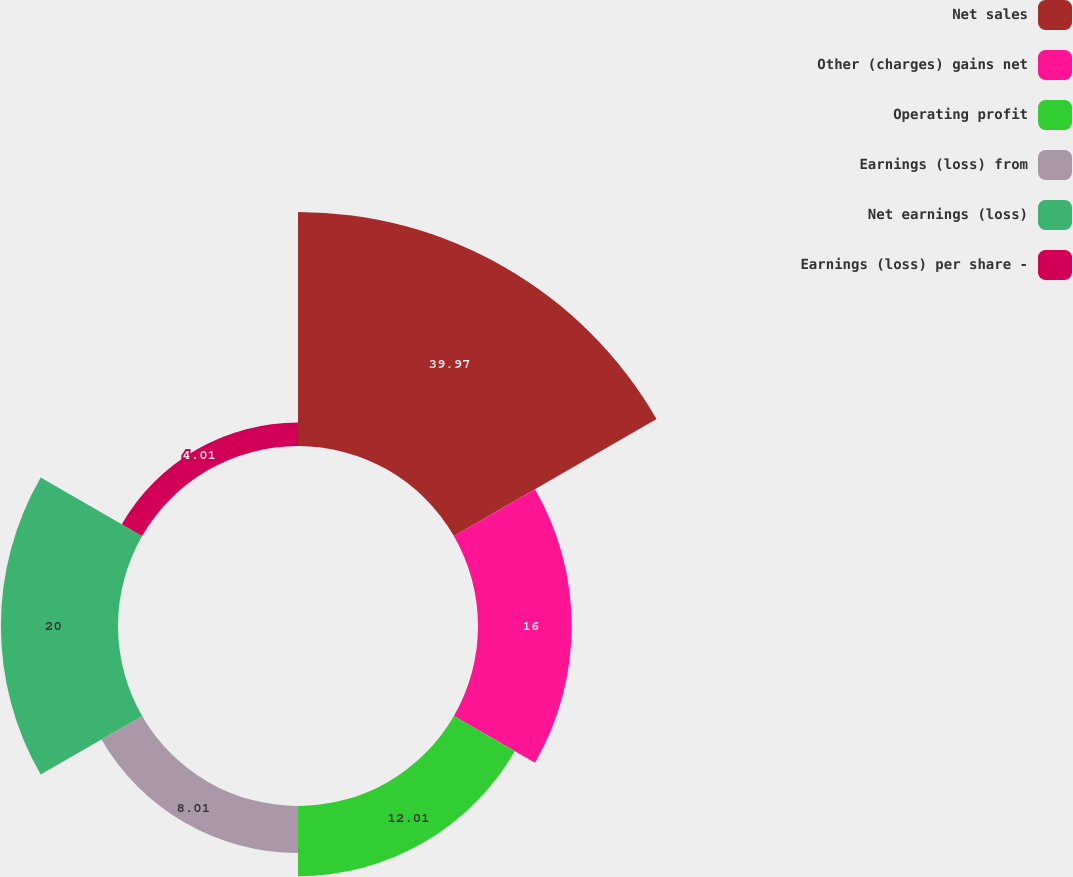Convert chart. <chart><loc_0><loc_0><loc_500><loc_500><pie_chart><fcel>Net sales<fcel>Other (charges) gains net<fcel>Operating profit<fcel>Earnings (loss) from<fcel>Net earnings (loss)<fcel>Earnings (loss) per share -<nl><fcel>39.97%<fcel>16.0%<fcel>12.01%<fcel>8.01%<fcel>20.0%<fcel>4.01%<nl></chart> 